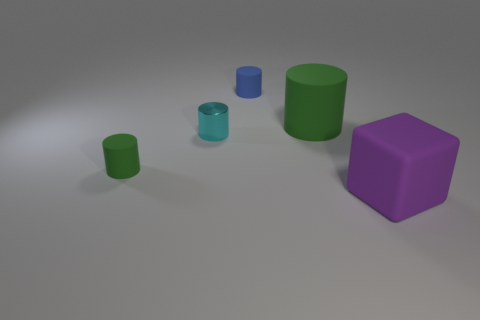Are there an equal number of big cylinders that are in front of the large green matte object and big gray rubber objects?
Give a very brief answer. Yes. Are there any other things that have the same material as the small green thing?
Offer a terse response. Yes. How many large things are either cyan cylinders or yellow balls?
Offer a very short reply. 0. What is the shape of the rubber object that is the same color as the big rubber cylinder?
Make the answer very short. Cylinder. Is the material of the tiny cylinder that is behind the cyan thing the same as the purple block?
Keep it short and to the point. Yes. The large cylinder right of the matte cylinder that is in front of the big matte cylinder is made of what material?
Provide a short and direct response. Rubber. What number of large purple shiny objects have the same shape as the small cyan object?
Ensure brevity in your answer.  0. What is the size of the matte cylinder to the right of the thing behind the cylinder that is right of the tiny blue rubber cylinder?
Offer a very short reply. Large. How many gray things are either small shiny cylinders or large cylinders?
Offer a very short reply. 0. There is a big thing that is on the left side of the purple rubber thing; is it the same shape as the small cyan shiny thing?
Your answer should be very brief. Yes. 